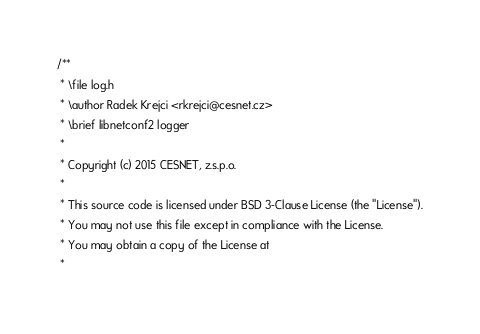Convert code to text. <code><loc_0><loc_0><loc_500><loc_500><_C_>/**
 * \file log.h
 * \author Radek Krejci <rkrejci@cesnet.cz>
 * \brief libnetconf2 logger
 *
 * Copyright (c) 2015 CESNET, z.s.p.o.
 *
 * This source code is licensed under BSD 3-Clause License (the "License").
 * You may not use this file except in compliance with the License.
 * You may obtain a copy of the License at
 *</code> 